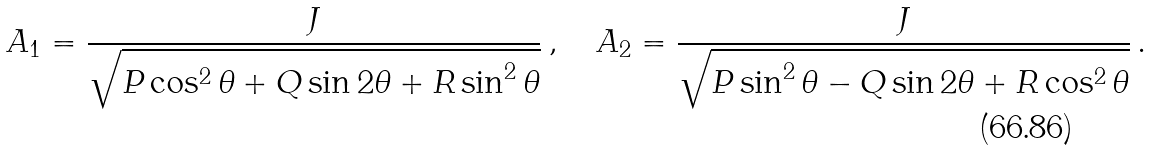<formula> <loc_0><loc_0><loc_500><loc_500>A _ { 1 } = \frac { J } { \sqrt { P \cos ^ { 2 } \theta + Q \sin 2 \theta + R \sin ^ { 2 } \theta } } \, , \quad A _ { 2 } = \frac { J } { \sqrt { P \sin ^ { 2 } \theta - Q \sin 2 \theta + R \cos ^ { 2 } \theta } } \, .</formula> 